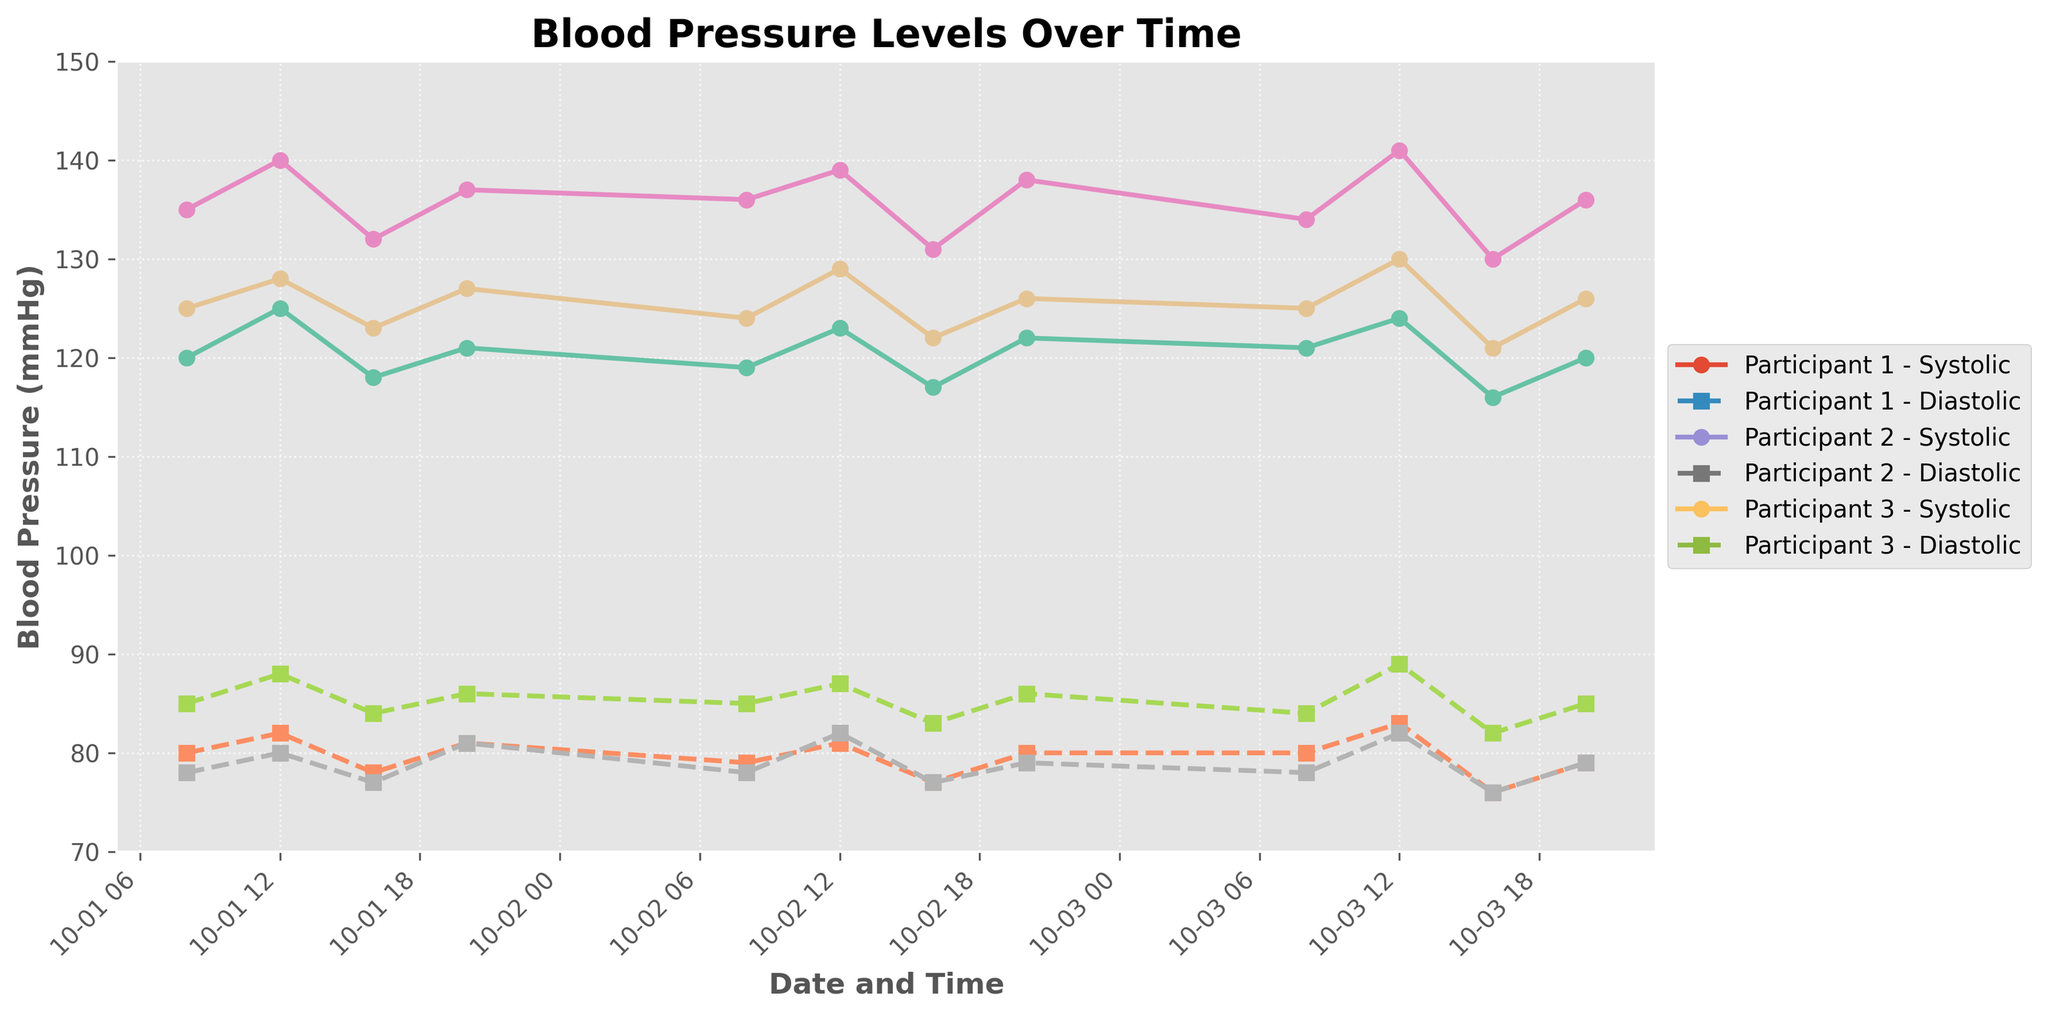What is the title of the plot? The title is displayed at the top of the figure. It reads "Blood Pressure Levels Over Time".
Answer: Blood Pressure Levels Over Time What are the y-axis limits? The y-axis ranges from 70 to 150, which can be seen by looking at the y-axis of the plot.
Answer: 70 to 150 How many participants' data are included in the plot? There are three distinct participants listed (Participant 1, Participant 2, and Participant 3) with separate lines for each participant in the legend.
Answer: 3 What do the markers 'o' and 's' represent in the plot? The markers 'o' and 's' represent the data points for Systolic BP and Diastolic BP, respectively. This can be inferred by looking at the legend.
Answer: 'o' for Systolic BP and 's' for Diastolic BP Which participant shows the highest Systolic BP reading, and what is the value? Participant 2 has the highest Systolic BP reading at 141 mmHg, which can be seen from the peak value in the time series data for Participant 2.
Answer: Participant 2, 141 mmHg On which date and time does Participant 1 have the lowest Diastolic BP reading? For Participant 1, the lowest Diastolic BP reading is 76 mmHg, observed on 2023-10-03 at 16:00. This can be noted by looking at the lowest points in Participant 1's Diastolic BP series.
Answer: 2023-10-03, 16:00 Compare the average Systolic BP of Participant 1 and Participant 3. Who has a higher average? To find the average Systolic BP, sum the Systolic BP points of Participant 1 and divide by the number of data points, then do the same for Participant 3. Participant 1: (120+125+118+121+119+123+117+122+121+124+116+120)/12 = 120.42, Participant 3: (125+128+123+127+124+129+122+126+125+130+121+126)/12 = 125.67. Hence, Participant 3 has a higher average.
Answer: Participant 3 How does Participant 2's BP trend from 08:00 to 20:00 on 2023-10-02? Participant 2's Systolic BP shows a minor fluctuation: starting at 136, peaking at 139 around noon, dropping to 131 at 16:00, and slightly increasing again to 138 by 20:00. The Diastolic BP similarly fluctuates.
Answer: Minor fluctuation with a peak at midday What is the general trend of Diastolic BP levels over the three days for Participant 3? Looking at the trend, Participant 3's Diastolic BP starts at around 78 and fluctuates slightly within a range but generally stays between 76 and 82 without any significant upward or downward trend.
Answer: Fluctuates within 76-82 Which participant has the most stable Diastolic BP readings over the given period? By visually inspecting the Diastolic BP readings, Participant 1's readings show the least variability and range between 76 to 83 compared to the others.
Answer: Participant 1 